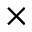<formula> <loc_0><loc_0><loc_500><loc_500>\times</formula> 